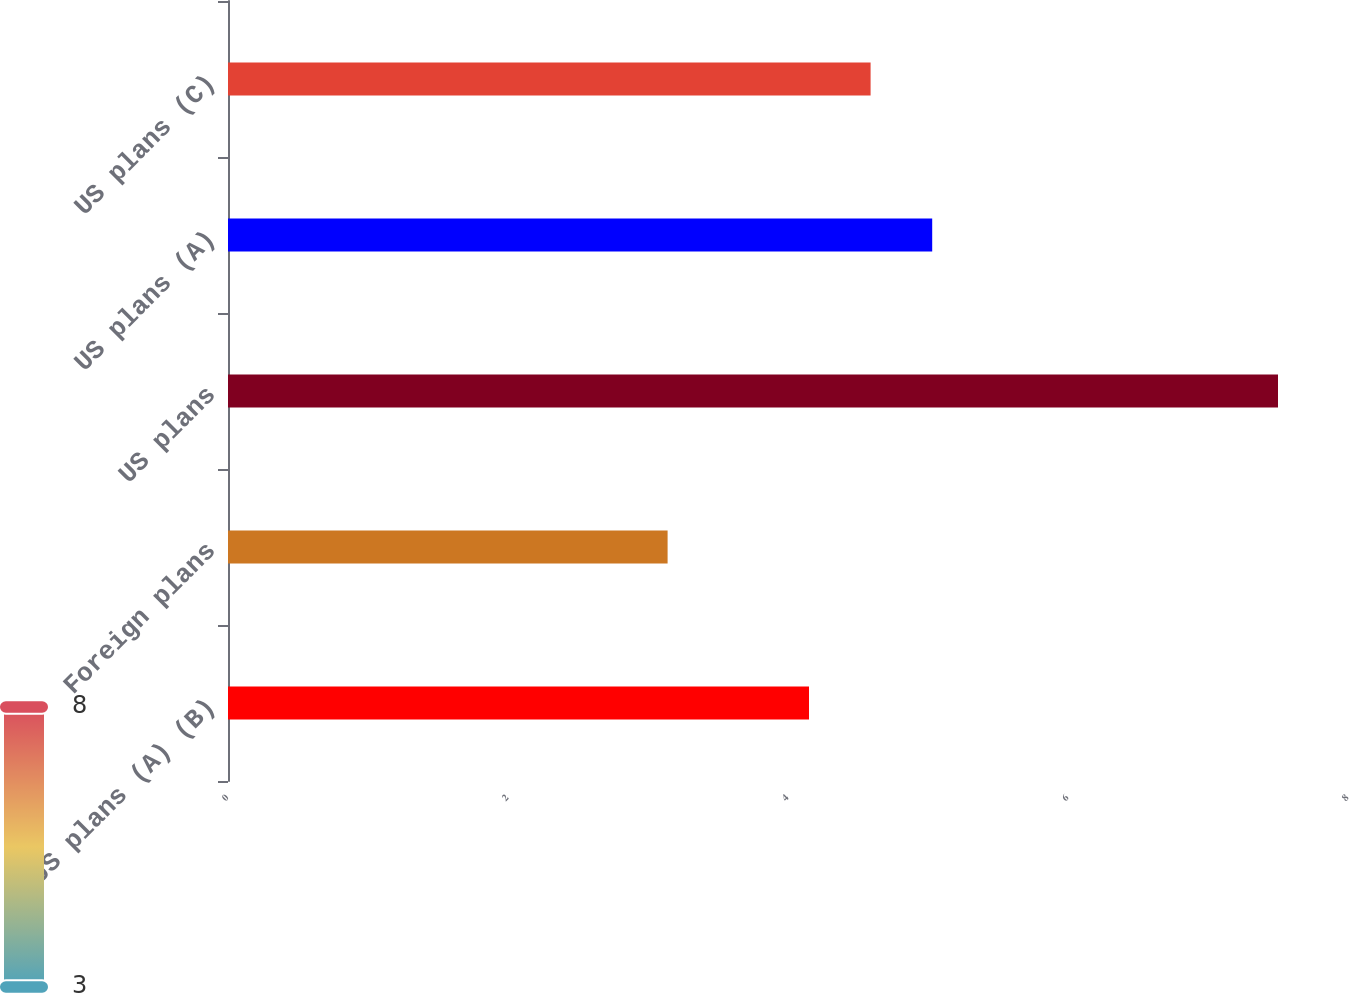Convert chart to OTSL. <chart><loc_0><loc_0><loc_500><loc_500><bar_chart><fcel>US plans (A) (B)<fcel>Foreign plans<fcel>US plans<fcel>US plans (A)<fcel>US plans (C)<nl><fcel>4.15<fcel>3.14<fcel>7.5<fcel>5.03<fcel>4.59<nl></chart> 